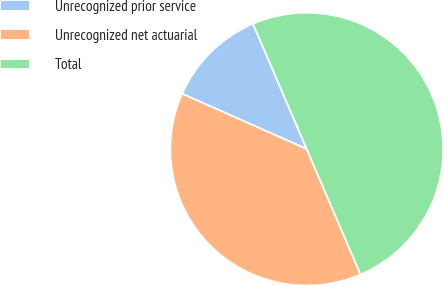Convert chart to OTSL. <chart><loc_0><loc_0><loc_500><loc_500><pie_chart><fcel>Unrecognized prior service<fcel>Unrecognized net actuarial<fcel>Total<nl><fcel>11.9%<fcel>38.1%<fcel>50.0%<nl></chart> 